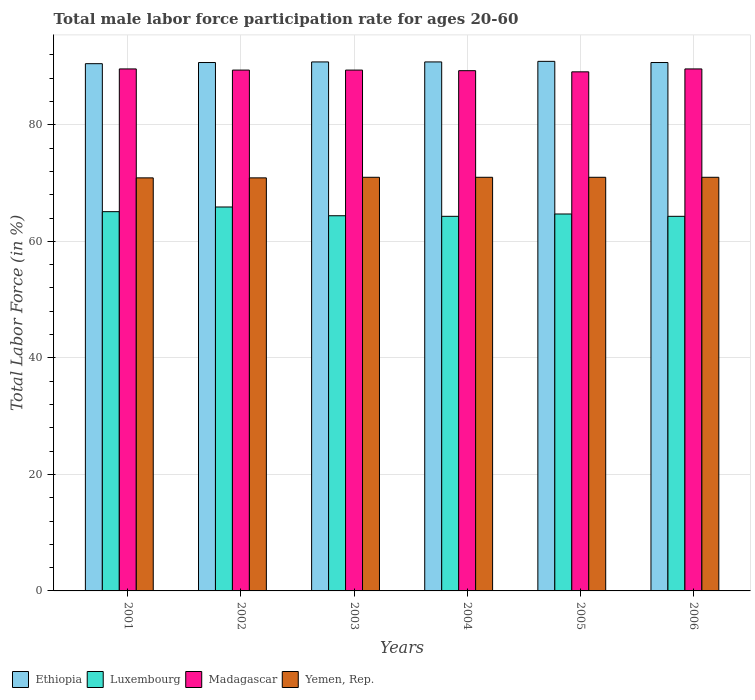How many groups of bars are there?
Provide a succinct answer. 6. What is the label of the 4th group of bars from the left?
Offer a terse response. 2004. In how many cases, is the number of bars for a given year not equal to the number of legend labels?
Keep it short and to the point. 0. What is the male labor force participation rate in Ethiopia in 2005?
Offer a very short reply. 90.9. Across all years, what is the minimum male labor force participation rate in Yemen, Rep.?
Provide a short and direct response. 70.9. What is the total male labor force participation rate in Luxembourg in the graph?
Make the answer very short. 388.7. What is the difference between the male labor force participation rate in Ethiopia in 2001 and that in 2006?
Your answer should be very brief. -0.2. What is the difference between the male labor force participation rate in Madagascar in 2005 and the male labor force participation rate in Yemen, Rep. in 2002?
Your answer should be compact. 18.2. What is the average male labor force participation rate in Ethiopia per year?
Ensure brevity in your answer.  90.73. In the year 2002, what is the difference between the male labor force participation rate in Madagascar and male labor force participation rate in Yemen, Rep.?
Your answer should be very brief. 18.5. In how many years, is the male labor force participation rate in Luxembourg greater than 56 %?
Your answer should be very brief. 6. What is the ratio of the male labor force participation rate in Luxembourg in 2001 to that in 2004?
Ensure brevity in your answer.  1.01. Is the male labor force participation rate in Luxembourg in 2003 less than that in 2006?
Offer a terse response. No. What is the difference between the highest and the second highest male labor force participation rate in Yemen, Rep.?
Your answer should be compact. 0. What is the difference between the highest and the lowest male labor force participation rate in Yemen, Rep.?
Your answer should be compact. 0.1. In how many years, is the male labor force participation rate in Madagascar greater than the average male labor force participation rate in Madagascar taken over all years?
Make the answer very short. 4. What does the 2nd bar from the left in 2002 represents?
Give a very brief answer. Luxembourg. What does the 4th bar from the right in 2001 represents?
Provide a succinct answer. Ethiopia. Is it the case that in every year, the sum of the male labor force participation rate in Yemen, Rep. and male labor force participation rate in Luxembourg is greater than the male labor force participation rate in Ethiopia?
Your answer should be compact. Yes. Are all the bars in the graph horizontal?
Your response must be concise. No. How many years are there in the graph?
Your answer should be very brief. 6. What is the difference between two consecutive major ticks on the Y-axis?
Your answer should be very brief. 20. Does the graph contain any zero values?
Your answer should be very brief. No. What is the title of the graph?
Your answer should be very brief. Total male labor force participation rate for ages 20-60. What is the label or title of the Y-axis?
Your response must be concise. Total Labor Force (in %). What is the Total Labor Force (in %) of Ethiopia in 2001?
Offer a very short reply. 90.5. What is the Total Labor Force (in %) in Luxembourg in 2001?
Offer a very short reply. 65.1. What is the Total Labor Force (in %) of Madagascar in 2001?
Provide a succinct answer. 89.6. What is the Total Labor Force (in %) in Yemen, Rep. in 2001?
Your response must be concise. 70.9. What is the Total Labor Force (in %) in Ethiopia in 2002?
Your answer should be compact. 90.7. What is the Total Labor Force (in %) in Luxembourg in 2002?
Provide a short and direct response. 65.9. What is the Total Labor Force (in %) in Madagascar in 2002?
Provide a short and direct response. 89.4. What is the Total Labor Force (in %) of Yemen, Rep. in 2002?
Provide a succinct answer. 70.9. What is the Total Labor Force (in %) of Ethiopia in 2003?
Provide a succinct answer. 90.8. What is the Total Labor Force (in %) in Luxembourg in 2003?
Your response must be concise. 64.4. What is the Total Labor Force (in %) in Madagascar in 2003?
Provide a short and direct response. 89.4. What is the Total Labor Force (in %) of Ethiopia in 2004?
Provide a short and direct response. 90.8. What is the Total Labor Force (in %) in Luxembourg in 2004?
Make the answer very short. 64.3. What is the Total Labor Force (in %) in Madagascar in 2004?
Your answer should be very brief. 89.3. What is the Total Labor Force (in %) in Yemen, Rep. in 2004?
Your response must be concise. 71. What is the Total Labor Force (in %) of Ethiopia in 2005?
Give a very brief answer. 90.9. What is the Total Labor Force (in %) in Luxembourg in 2005?
Offer a very short reply. 64.7. What is the Total Labor Force (in %) of Madagascar in 2005?
Give a very brief answer. 89.1. What is the Total Labor Force (in %) in Ethiopia in 2006?
Ensure brevity in your answer.  90.7. What is the Total Labor Force (in %) in Luxembourg in 2006?
Keep it short and to the point. 64.3. What is the Total Labor Force (in %) of Madagascar in 2006?
Offer a terse response. 89.6. What is the Total Labor Force (in %) in Yemen, Rep. in 2006?
Provide a succinct answer. 71. Across all years, what is the maximum Total Labor Force (in %) of Ethiopia?
Your answer should be compact. 90.9. Across all years, what is the maximum Total Labor Force (in %) in Luxembourg?
Keep it short and to the point. 65.9. Across all years, what is the maximum Total Labor Force (in %) in Madagascar?
Offer a terse response. 89.6. Across all years, what is the maximum Total Labor Force (in %) of Yemen, Rep.?
Ensure brevity in your answer.  71. Across all years, what is the minimum Total Labor Force (in %) in Ethiopia?
Your answer should be compact. 90.5. Across all years, what is the minimum Total Labor Force (in %) of Luxembourg?
Provide a succinct answer. 64.3. Across all years, what is the minimum Total Labor Force (in %) of Madagascar?
Your answer should be very brief. 89.1. Across all years, what is the minimum Total Labor Force (in %) in Yemen, Rep.?
Provide a short and direct response. 70.9. What is the total Total Labor Force (in %) of Ethiopia in the graph?
Your response must be concise. 544.4. What is the total Total Labor Force (in %) of Luxembourg in the graph?
Provide a short and direct response. 388.7. What is the total Total Labor Force (in %) of Madagascar in the graph?
Your response must be concise. 536.4. What is the total Total Labor Force (in %) of Yemen, Rep. in the graph?
Your response must be concise. 425.8. What is the difference between the Total Labor Force (in %) of Luxembourg in 2001 and that in 2003?
Your response must be concise. 0.7. What is the difference between the Total Labor Force (in %) in Yemen, Rep. in 2001 and that in 2003?
Your response must be concise. -0.1. What is the difference between the Total Labor Force (in %) in Luxembourg in 2001 and that in 2005?
Your answer should be compact. 0.4. What is the difference between the Total Labor Force (in %) of Madagascar in 2001 and that in 2005?
Your answer should be very brief. 0.5. What is the difference between the Total Labor Force (in %) of Madagascar in 2001 and that in 2006?
Your response must be concise. 0. What is the difference between the Total Labor Force (in %) in Yemen, Rep. in 2001 and that in 2006?
Ensure brevity in your answer.  -0.1. What is the difference between the Total Labor Force (in %) of Ethiopia in 2002 and that in 2005?
Your answer should be compact. -0.2. What is the difference between the Total Labor Force (in %) in Yemen, Rep. in 2002 and that in 2005?
Keep it short and to the point. -0.1. What is the difference between the Total Labor Force (in %) of Luxembourg in 2002 and that in 2006?
Offer a terse response. 1.6. What is the difference between the Total Labor Force (in %) of Madagascar in 2002 and that in 2006?
Offer a terse response. -0.2. What is the difference between the Total Labor Force (in %) in Yemen, Rep. in 2002 and that in 2006?
Provide a succinct answer. -0.1. What is the difference between the Total Labor Force (in %) of Madagascar in 2003 and that in 2004?
Give a very brief answer. 0.1. What is the difference between the Total Labor Force (in %) in Yemen, Rep. in 2003 and that in 2004?
Ensure brevity in your answer.  0. What is the difference between the Total Labor Force (in %) in Madagascar in 2003 and that in 2005?
Offer a very short reply. 0.3. What is the difference between the Total Labor Force (in %) of Luxembourg in 2003 and that in 2006?
Offer a terse response. 0.1. What is the difference between the Total Labor Force (in %) of Madagascar in 2003 and that in 2006?
Keep it short and to the point. -0.2. What is the difference between the Total Labor Force (in %) in Luxembourg in 2004 and that in 2005?
Provide a short and direct response. -0.4. What is the difference between the Total Labor Force (in %) of Madagascar in 2004 and that in 2005?
Offer a very short reply. 0.2. What is the difference between the Total Labor Force (in %) in Luxembourg in 2004 and that in 2006?
Ensure brevity in your answer.  0. What is the difference between the Total Labor Force (in %) of Yemen, Rep. in 2004 and that in 2006?
Give a very brief answer. 0. What is the difference between the Total Labor Force (in %) of Ethiopia in 2001 and the Total Labor Force (in %) of Luxembourg in 2002?
Provide a short and direct response. 24.6. What is the difference between the Total Labor Force (in %) in Ethiopia in 2001 and the Total Labor Force (in %) in Yemen, Rep. in 2002?
Offer a terse response. 19.6. What is the difference between the Total Labor Force (in %) in Luxembourg in 2001 and the Total Labor Force (in %) in Madagascar in 2002?
Provide a succinct answer. -24.3. What is the difference between the Total Labor Force (in %) in Luxembourg in 2001 and the Total Labor Force (in %) in Yemen, Rep. in 2002?
Your response must be concise. -5.8. What is the difference between the Total Labor Force (in %) of Madagascar in 2001 and the Total Labor Force (in %) of Yemen, Rep. in 2002?
Offer a terse response. 18.7. What is the difference between the Total Labor Force (in %) in Ethiopia in 2001 and the Total Labor Force (in %) in Luxembourg in 2003?
Provide a succinct answer. 26.1. What is the difference between the Total Labor Force (in %) in Ethiopia in 2001 and the Total Labor Force (in %) in Yemen, Rep. in 2003?
Provide a succinct answer. 19.5. What is the difference between the Total Labor Force (in %) of Luxembourg in 2001 and the Total Labor Force (in %) of Madagascar in 2003?
Provide a succinct answer. -24.3. What is the difference between the Total Labor Force (in %) of Ethiopia in 2001 and the Total Labor Force (in %) of Luxembourg in 2004?
Make the answer very short. 26.2. What is the difference between the Total Labor Force (in %) in Ethiopia in 2001 and the Total Labor Force (in %) in Madagascar in 2004?
Your answer should be compact. 1.2. What is the difference between the Total Labor Force (in %) of Ethiopia in 2001 and the Total Labor Force (in %) of Yemen, Rep. in 2004?
Your answer should be compact. 19.5. What is the difference between the Total Labor Force (in %) of Luxembourg in 2001 and the Total Labor Force (in %) of Madagascar in 2004?
Keep it short and to the point. -24.2. What is the difference between the Total Labor Force (in %) in Luxembourg in 2001 and the Total Labor Force (in %) in Yemen, Rep. in 2004?
Keep it short and to the point. -5.9. What is the difference between the Total Labor Force (in %) of Ethiopia in 2001 and the Total Labor Force (in %) of Luxembourg in 2005?
Offer a terse response. 25.8. What is the difference between the Total Labor Force (in %) in Ethiopia in 2001 and the Total Labor Force (in %) in Madagascar in 2005?
Provide a short and direct response. 1.4. What is the difference between the Total Labor Force (in %) in Ethiopia in 2001 and the Total Labor Force (in %) in Yemen, Rep. in 2005?
Your response must be concise. 19.5. What is the difference between the Total Labor Force (in %) in Luxembourg in 2001 and the Total Labor Force (in %) in Madagascar in 2005?
Ensure brevity in your answer.  -24. What is the difference between the Total Labor Force (in %) of Madagascar in 2001 and the Total Labor Force (in %) of Yemen, Rep. in 2005?
Your response must be concise. 18.6. What is the difference between the Total Labor Force (in %) in Ethiopia in 2001 and the Total Labor Force (in %) in Luxembourg in 2006?
Your answer should be very brief. 26.2. What is the difference between the Total Labor Force (in %) in Ethiopia in 2001 and the Total Labor Force (in %) in Madagascar in 2006?
Your answer should be very brief. 0.9. What is the difference between the Total Labor Force (in %) in Ethiopia in 2001 and the Total Labor Force (in %) in Yemen, Rep. in 2006?
Your response must be concise. 19.5. What is the difference between the Total Labor Force (in %) in Luxembourg in 2001 and the Total Labor Force (in %) in Madagascar in 2006?
Keep it short and to the point. -24.5. What is the difference between the Total Labor Force (in %) of Luxembourg in 2001 and the Total Labor Force (in %) of Yemen, Rep. in 2006?
Your answer should be compact. -5.9. What is the difference between the Total Labor Force (in %) in Ethiopia in 2002 and the Total Labor Force (in %) in Luxembourg in 2003?
Offer a terse response. 26.3. What is the difference between the Total Labor Force (in %) in Ethiopia in 2002 and the Total Labor Force (in %) in Madagascar in 2003?
Your response must be concise. 1.3. What is the difference between the Total Labor Force (in %) of Ethiopia in 2002 and the Total Labor Force (in %) of Yemen, Rep. in 2003?
Your response must be concise. 19.7. What is the difference between the Total Labor Force (in %) in Luxembourg in 2002 and the Total Labor Force (in %) in Madagascar in 2003?
Make the answer very short. -23.5. What is the difference between the Total Labor Force (in %) in Madagascar in 2002 and the Total Labor Force (in %) in Yemen, Rep. in 2003?
Your answer should be very brief. 18.4. What is the difference between the Total Labor Force (in %) in Ethiopia in 2002 and the Total Labor Force (in %) in Luxembourg in 2004?
Your answer should be very brief. 26.4. What is the difference between the Total Labor Force (in %) in Ethiopia in 2002 and the Total Labor Force (in %) in Yemen, Rep. in 2004?
Offer a terse response. 19.7. What is the difference between the Total Labor Force (in %) in Luxembourg in 2002 and the Total Labor Force (in %) in Madagascar in 2004?
Your response must be concise. -23.4. What is the difference between the Total Labor Force (in %) of Ethiopia in 2002 and the Total Labor Force (in %) of Luxembourg in 2005?
Your answer should be very brief. 26. What is the difference between the Total Labor Force (in %) in Ethiopia in 2002 and the Total Labor Force (in %) in Madagascar in 2005?
Provide a succinct answer. 1.6. What is the difference between the Total Labor Force (in %) in Ethiopia in 2002 and the Total Labor Force (in %) in Yemen, Rep. in 2005?
Ensure brevity in your answer.  19.7. What is the difference between the Total Labor Force (in %) of Luxembourg in 2002 and the Total Labor Force (in %) of Madagascar in 2005?
Ensure brevity in your answer.  -23.2. What is the difference between the Total Labor Force (in %) in Luxembourg in 2002 and the Total Labor Force (in %) in Yemen, Rep. in 2005?
Give a very brief answer. -5.1. What is the difference between the Total Labor Force (in %) in Ethiopia in 2002 and the Total Labor Force (in %) in Luxembourg in 2006?
Your answer should be very brief. 26.4. What is the difference between the Total Labor Force (in %) of Ethiopia in 2002 and the Total Labor Force (in %) of Madagascar in 2006?
Keep it short and to the point. 1.1. What is the difference between the Total Labor Force (in %) in Ethiopia in 2002 and the Total Labor Force (in %) in Yemen, Rep. in 2006?
Offer a terse response. 19.7. What is the difference between the Total Labor Force (in %) of Luxembourg in 2002 and the Total Labor Force (in %) of Madagascar in 2006?
Offer a terse response. -23.7. What is the difference between the Total Labor Force (in %) in Luxembourg in 2002 and the Total Labor Force (in %) in Yemen, Rep. in 2006?
Offer a terse response. -5.1. What is the difference between the Total Labor Force (in %) of Ethiopia in 2003 and the Total Labor Force (in %) of Luxembourg in 2004?
Make the answer very short. 26.5. What is the difference between the Total Labor Force (in %) of Ethiopia in 2003 and the Total Labor Force (in %) of Yemen, Rep. in 2004?
Ensure brevity in your answer.  19.8. What is the difference between the Total Labor Force (in %) of Luxembourg in 2003 and the Total Labor Force (in %) of Madagascar in 2004?
Provide a short and direct response. -24.9. What is the difference between the Total Labor Force (in %) of Ethiopia in 2003 and the Total Labor Force (in %) of Luxembourg in 2005?
Offer a very short reply. 26.1. What is the difference between the Total Labor Force (in %) of Ethiopia in 2003 and the Total Labor Force (in %) of Madagascar in 2005?
Ensure brevity in your answer.  1.7. What is the difference between the Total Labor Force (in %) in Ethiopia in 2003 and the Total Labor Force (in %) in Yemen, Rep. in 2005?
Provide a succinct answer. 19.8. What is the difference between the Total Labor Force (in %) in Luxembourg in 2003 and the Total Labor Force (in %) in Madagascar in 2005?
Provide a succinct answer. -24.7. What is the difference between the Total Labor Force (in %) in Madagascar in 2003 and the Total Labor Force (in %) in Yemen, Rep. in 2005?
Provide a short and direct response. 18.4. What is the difference between the Total Labor Force (in %) of Ethiopia in 2003 and the Total Labor Force (in %) of Luxembourg in 2006?
Provide a short and direct response. 26.5. What is the difference between the Total Labor Force (in %) of Ethiopia in 2003 and the Total Labor Force (in %) of Yemen, Rep. in 2006?
Offer a terse response. 19.8. What is the difference between the Total Labor Force (in %) in Luxembourg in 2003 and the Total Labor Force (in %) in Madagascar in 2006?
Make the answer very short. -25.2. What is the difference between the Total Labor Force (in %) in Luxembourg in 2003 and the Total Labor Force (in %) in Yemen, Rep. in 2006?
Offer a terse response. -6.6. What is the difference between the Total Labor Force (in %) in Ethiopia in 2004 and the Total Labor Force (in %) in Luxembourg in 2005?
Give a very brief answer. 26.1. What is the difference between the Total Labor Force (in %) of Ethiopia in 2004 and the Total Labor Force (in %) of Madagascar in 2005?
Your response must be concise. 1.7. What is the difference between the Total Labor Force (in %) in Ethiopia in 2004 and the Total Labor Force (in %) in Yemen, Rep. in 2005?
Make the answer very short. 19.8. What is the difference between the Total Labor Force (in %) in Luxembourg in 2004 and the Total Labor Force (in %) in Madagascar in 2005?
Give a very brief answer. -24.8. What is the difference between the Total Labor Force (in %) of Luxembourg in 2004 and the Total Labor Force (in %) of Yemen, Rep. in 2005?
Give a very brief answer. -6.7. What is the difference between the Total Labor Force (in %) of Ethiopia in 2004 and the Total Labor Force (in %) of Madagascar in 2006?
Make the answer very short. 1.2. What is the difference between the Total Labor Force (in %) of Ethiopia in 2004 and the Total Labor Force (in %) of Yemen, Rep. in 2006?
Offer a very short reply. 19.8. What is the difference between the Total Labor Force (in %) in Luxembourg in 2004 and the Total Labor Force (in %) in Madagascar in 2006?
Your answer should be very brief. -25.3. What is the difference between the Total Labor Force (in %) of Ethiopia in 2005 and the Total Labor Force (in %) of Luxembourg in 2006?
Your answer should be very brief. 26.6. What is the difference between the Total Labor Force (in %) in Ethiopia in 2005 and the Total Labor Force (in %) in Yemen, Rep. in 2006?
Provide a succinct answer. 19.9. What is the difference between the Total Labor Force (in %) of Luxembourg in 2005 and the Total Labor Force (in %) of Madagascar in 2006?
Your answer should be very brief. -24.9. What is the difference between the Total Labor Force (in %) of Luxembourg in 2005 and the Total Labor Force (in %) of Yemen, Rep. in 2006?
Offer a very short reply. -6.3. What is the difference between the Total Labor Force (in %) of Madagascar in 2005 and the Total Labor Force (in %) of Yemen, Rep. in 2006?
Give a very brief answer. 18.1. What is the average Total Labor Force (in %) in Ethiopia per year?
Your answer should be compact. 90.73. What is the average Total Labor Force (in %) of Luxembourg per year?
Ensure brevity in your answer.  64.78. What is the average Total Labor Force (in %) of Madagascar per year?
Offer a terse response. 89.4. What is the average Total Labor Force (in %) of Yemen, Rep. per year?
Keep it short and to the point. 70.97. In the year 2001, what is the difference between the Total Labor Force (in %) in Ethiopia and Total Labor Force (in %) in Luxembourg?
Offer a very short reply. 25.4. In the year 2001, what is the difference between the Total Labor Force (in %) of Ethiopia and Total Labor Force (in %) of Madagascar?
Ensure brevity in your answer.  0.9. In the year 2001, what is the difference between the Total Labor Force (in %) in Ethiopia and Total Labor Force (in %) in Yemen, Rep.?
Make the answer very short. 19.6. In the year 2001, what is the difference between the Total Labor Force (in %) of Luxembourg and Total Labor Force (in %) of Madagascar?
Make the answer very short. -24.5. In the year 2001, what is the difference between the Total Labor Force (in %) in Luxembourg and Total Labor Force (in %) in Yemen, Rep.?
Keep it short and to the point. -5.8. In the year 2002, what is the difference between the Total Labor Force (in %) in Ethiopia and Total Labor Force (in %) in Luxembourg?
Provide a succinct answer. 24.8. In the year 2002, what is the difference between the Total Labor Force (in %) of Ethiopia and Total Labor Force (in %) of Yemen, Rep.?
Your response must be concise. 19.8. In the year 2002, what is the difference between the Total Labor Force (in %) in Luxembourg and Total Labor Force (in %) in Madagascar?
Offer a very short reply. -23.5. In the year 2002, what is the difference between the Total Labor Force (in %) in Luxembourg and Total Labor Force (in %) in Yemen, Rep.?
Ensure brevity in your answer.  -5. In the year 2002, what is the difference between the Total Labor Force (in %) of Madagascar and Total Labor Force (in %) of Yemen, Rep.?
Give a very brief answer. 18.5. In the year 2003, what is the difference between the Total Labor Force (in %) in Ethiopia and Total Labor Force (in %) in Luxembourg?
Your answer should be very brief. 26.4. In the year 2003, what is the difference between the Total Labor Force (in %) in Ethiopia and Total Labor Force (in %) in Madagascar?
Your answer should be very brief. 1.4. In the year 2003, what is the difference between the Total Labor Force (in %) of Ethiopia and Total Labor Force (in %) of Yemen, Rep.?
Ensure brevity in your answer.  19.8. In the year 2003, what is the difference between the Total Labor Force (in %) in Luxembourg and Total Labor Force (in %) in Madagascar?
Ensure brevity in your answer.  -25. In the year 2004, what is the difference between the Total Labor Force (in %) of Ethiopia and Total Labor Force (in %) of Madagascar?
Provide a succinct answer. 1.5. In the year 2004, what is the difference between the Total Labor Force (in %) in Ethiopia and Total Labor Force (in %) in Yemen, Rep.?
Give a very brief answer. 19.8. In the year 2004, what is the difference between the Total Labor Force (in %) of Luxembourg and Total Labor Force (in %) of Madagascar?
Your response must be concise. -25. In the year 2004, what is the difference between the Total Labor Force (in %) in Luxembourg and Total Labor Force (in %) in Yemen, Rep.?
Keep it short and to the point. -6.7. In the year 2005, what is the difference between the Total Labor Force (in %) of Ethiopia and Total Labor Force (in %) of Luxembourg?
Make the answer very short. 26.2. In the year 2005, what is the difference between the Total Labor Force (in %) in Ethiopia and Total Labor Force (in %) in Yemen, Rep.?
Offer a very short reply. 19.9. In the year 2005, what is the difference between the Total Labor Force (in %) in Luxembourg and Total Labor Force (in %) in Madagascar?
Your answer should be compact. -24.4. In the year 2005, what is the difference between the Total Labor Force (in %) in Luxembourg and Total Labor Force (in %) in Yemen, Rep.?
Offer a very short reply. -6.3. In the year 2006, what is the difference between the Total Labor Force (in %) in Ethiopia and Total Labor Force (in %) in Luxembourg?
Offer a terse response. 26.4. In the year 2006, what is the difference between the Total Labor Force (in %) of Ethiopia and Total Labor Force (in %) of Madagascar?
Your response must be concise. 1.1. In the year 2006, what is the difference between the Total Labor Force (in %) in Luxembourg and Total Labor Force (in %) in Madagascar?
Offer a terse response. -25.3. In the year 2006, what is the difference between the Total Labor Force (in %) of Madagascar and Total Labor Force (in %) of Yemen, Rep.?
Offer a very short reply. 18.6. What is the ratio of the Total Labor Force (in %) of Luxembourg in 2001 to that in 2002?
Make the answer very short. 0.99. What is the ratio of the Total Labor Force (in %) of Madagascar in 2001 to that in 2002?
Give a very brief answer. 1. What is the ratio of the Total Labor Force (in %) of Ethiopia in 2001 to that in 2003?
Offer a terse response. 1. What is the ratio of the Total Labor Force (in %) in Luxembourg in 2001 to that in 2003?
Make the answer very short. 1.01. What is the ratio of the Total Labor Force (in %) of Luxembourg in 2001 to that in 2004?
Provide a short and direct response. 1.01. What is the ratio of the Total Labor Force (in %) in Madagascar in 2001 to that in 2004?
Ensure brevity in your answer.  1. What is the ratio of the Total Labor Force (in %) in Luxembourg in 2001 to that in 2005?
Give a very brief answer. 1.01. What is the ratio of the Total Labor Force (in %) of Madagascar in 2001 to that in 2005?
Ensure brevity in your answer.  1.01. What is the ratio of the Total Labor Force (in %) in Luxembourg in 2001 to that in 2006?
Give a very brief answer. 1.01. What is the ratio of the Total Labor Force (in %) in Ethiopia in 2002 to that in 2003?
Offer a terse response. 1. What is the ratio of the Total Labor Force (in %) in Luxembourg in 2002 to that in 2003?
Give a very brief answer. 1.02. What is the ratio of the Total Labor Force (in %) of Ethiopia in 2002 to that in 2004?
Give a very brief answer. 1. What is the ratio of the Total Labor Force (in %) in Luxembourg in 2002 to that in 2004?
Ensure brevity in your answer.  1.02. What is the ratio of the Total Labor Force (in %) in Madagascar in 2002 to that in 2004?
Your answer should be very brief. 1. What is the ratio of the Total Labor Force (in %) in Yemen, Rep. in 2002 to that in 2004?
Give a very brief answer. 1. What is the ratio of the Total Labor Force (in %) of Ethiopia in 2002 to that in 2005?
Your response must be concise. 1. What is the ratio of the Total Labor Force (in %) in Luxembourg in 2002 to that in 2005?
Offer a terse response. 1.02. What is the ratio of the Total Labor Force (in %) of Luxembourg in 2002 to that in 2006?
Ensure brevity in your answer.  1.02. What is the ratio of the Total Labor Force (in %) in Madagascar in 2002 to that in 2006?
Your answer should be very brief. 1. What is the ratio of the Total Labor Force (in %) in Luxembourg in 2003 to that in 2004?
Your answer should be compact. 1. What is the ratio of the Total Labor Force (in %) of Luxembourg in 2003 to that in 2005?
Offer a very short reply. 1. What is the ratio of the Total Labor Force (in %) of Yemen, Rep. in 2003 to that in 2005?
Give a very brief answer. 1. What is the ratio of the Total Labor Force (in %) of Ethiopia in 2003 to that in 2006?
Your answer should be very brief. 1. What is the ratio of the Total Labor Force (in %) in Luxembourg in 2003 to that in 2006?
Give a very brief answer. 1. What is the ratio of the Total Labor Force (in %) in Madagascar in 2003 to that in 2006?
Your response must be concise. 1. What is the ratio of the Total Labor Force (in %) of Luxembourg in 2004 to that in 2005?
Your response must be concise. 0.99. What is the ratio of the Total Labor Force (in %) in Madagascar in 2004 to that in 2005?
Make the answer very short. 1. What is the ratio of the Total Labor Force (in %) in Ethiopia in 2004 to that in 2006?
Your response must be concise. 1. What is the ratio of the Total Labor Force (in %) in Luxembourg in 2004 to that in 2006?
Offer a very short reply. 1. What is the ratio of the Total Labor Force (in %) in Madagascar in 2004 to that in 2006?
Offer a very short reply. 1. What is the ratio of the Total Labor Force (in %) of Ethiopia in 2005 to that in 2006?
Your answer should be compact. 1. What is the ratio of the Total Labor Force (in %) in Luxembourg in 2005 to that in 2006?
Offer a very short reply. 1.01. What is the difference between the highest and the second highest Total Labor Force (in %) in Luxembourg?
Your answer should be very brief. 0.8. What is the difference between the highest and the second highest Total Labor Force (in %) of Yemen, Rep.?
Your answer should be very brief. 0. What is the difference between the highest and the lowest Total Labor Force (in %) in Luxembourg?
Your response must be concise. 1.6. What is the difference between the highest and the lowest Total Labor Force (in %) of Yemen, Rep.?
Ensure brevity in your answer.  0.1. 